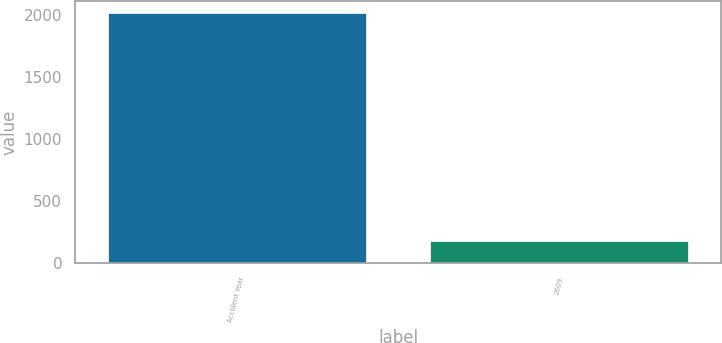Convert chart. <chart><loc_0><loc_0><loc_500><loc_500><bar_chart><fcel>Accident Year<fcel>2009<nl><fcel>2011<fcel>175<nl></chart> 